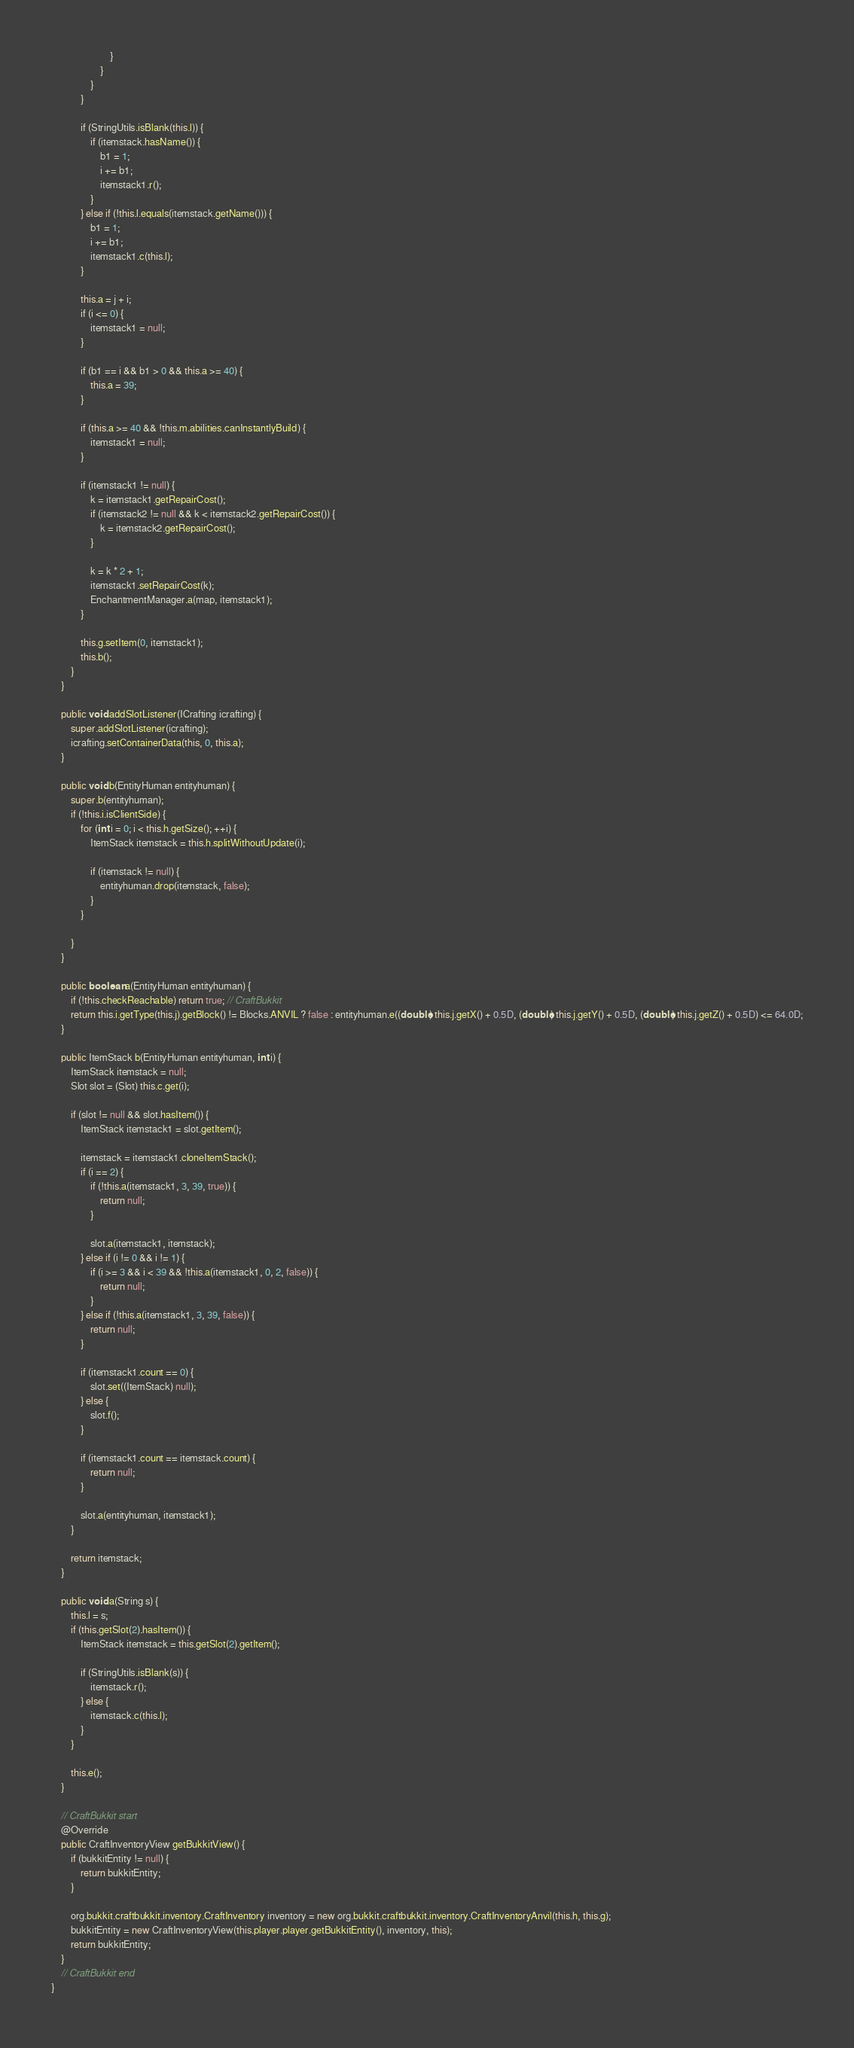Convert code to text. <code><loc_0><loc_0><loc_500><loc_500><_Java_>                        }
                    }
                }
            }

            if (StringUtils.isBlank(this.l)) {
                if (itemstack.hasName()) {
                    b1 = 1;
                    i += b1;
                    itemstack1.r();
                }
            } else if (!this.l.equals(itemstack.getName())) {
                b1 = 1;
                i += b1;
                itemstack1.c(this.l);
            }

            this.a = j + i;
            if (i <= 0) {
                itemstack1 = null;
            }

            if (b1 == i && b1 > 0 && this.a >= 40) {
                this.a = 39;
            }

            if (this.a >= 40 && !this.m.abilities.canInstantlyBuild) {
                itemstack1 = null;
            }

            if (itemstack1 != null) {
                k = itemstack1.getRepairCost();
                if (itemstack2 != null && k < itemstack2.getRepairCost()) {
                    k = itemstack2.getRepairCost();
                }

                k = k * 2 + 1;
                itemstack1.setRepairCost(k);
                EnchantmentManager.a(map, itemstack1);
            }

            this.g.setItem(0, itemstack1);
            this.b();
        }
    }

    public void addSlotListener(ICrafting icrafting) {
        super.addSlotListener(icrafting);
        icrafting.setContainerData(this, 0, this.a);
    }

    public void b(EntityHuman entityhuman) {
        super.b(entityhuman);
        if (!this.i.isClientSide) {
            for (int i = 0; i < this.h.getSize(); ++i) {
                ItemStack itemstack = this.h.splitWithoutUpdate(i);

                if (itemstack != null) {
                    entityhuman.drop(itemstack, false);
                }
            }

        }
    }

    public boolean a(EntityHuman entityhuman) {
        if (!this.checkReachable) return true; // CraftBukkit
        return this.i.getType(this.j).getBlock() != Blocks.ANVIL ? false : entityhuman.e((double) this.j.getX() + 0.5D, (double) this.j.getY() + 0.5D, (double) this.j.getZ() + 0.5D) <= 64.0D;
    }

    public ItemStack b(EntityHuman entityhuman, int i) {
        ItemStack itemstack = null;
        Slot slot = (Slot) this.c.get(i);

        if (slot != null && slot.hasItem()) {
            ItemStack itemstack1 = slot.getItem();

            itemstack = itemstack1.cloneItemStack();
            if (i == 2) {
                if (!this.a(itemstack1, 3, 39, true)) {
                    return null;
                }

                slot.a(itemstack1, itemstack);
            } else if (i != 0 && i != 1) {
                if (i >= 3 && i < 39 && !this.a(itemstack1, 0, 2, false)) {
                    return null;
                }
            } else if (!this.a(itemstack1, 3, 39, false)) {
                return null;
            }

            if (itemstack1.count == 0) {
                slot.set((ItemStack) null);
            } else {
                slot.f();
            }

            if (itemstack1.count == itemstack.count) {
                return null;
            }

            slot.a(entityhuman, itemstack1);
        }

        return itemstack;
    }

    public void a(String s) {
        this.l = s;
        if (this.getSlot(2).hasItem()) {
            ItemStack itemstack = this.getSlot(2).getItem();

            if (StringUtils.isBlank(s)) {
                itemstack.r();
            } else {
                itemstack.c(this.l);
            }
        }

        this.e();
    }

    // CraftBukkit start
    @Override
    public CraftInventoryView getBukkitView() {
        if (bukkitEntity != null) {
            return bukkitEntity;
        }

        org.bukkit.craftbukkit.inventory.CraftInventory inventory = new org.bukkit.craftbukkit.inventory.CraftInventoryAnvil(this.h, this.g);
        bukkitEntity = new CraftInventoryView(this.player.player.getBukkitEntity(), inventory, this);
        return bukkitEntity;
    }
    // CraftBukkit end
}
</code> 